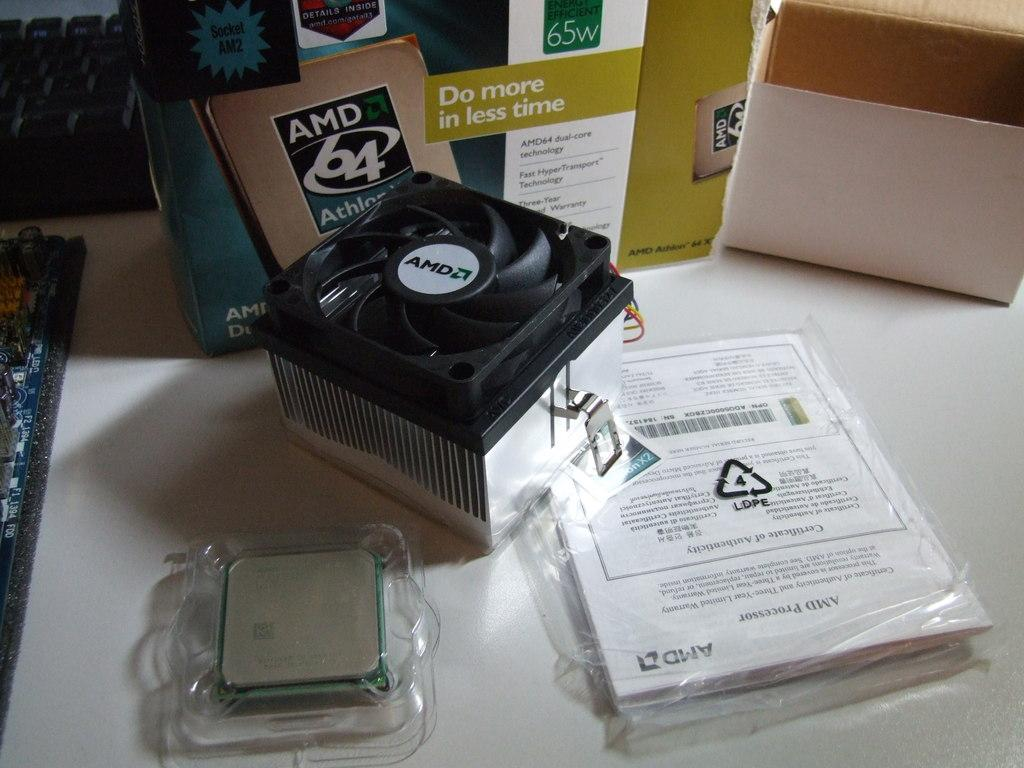<image>
Write a terse but informative summary of the picture. do more in less time is written on an item on the desk 